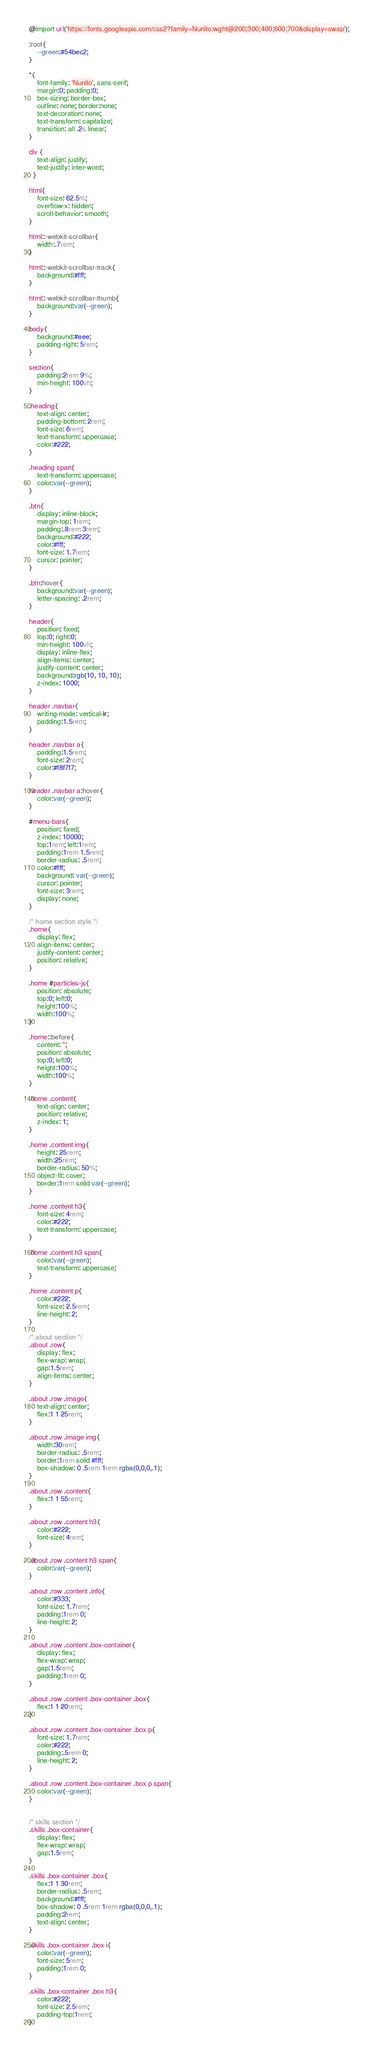<code> <loc_0><loc_0><loc_500><loc_500><_CSS_>@import url('https://fonts.googleapis.com/css2?family=Nunito:wght@200;300;400;600;700&display=swap');

:root{
    --green:#54bec2;
}

*{
    font-family: 'Nunito', sans-serif;
    margin:0; padding:0;
    box-sizing: border-box;
    outline: none; border:none;
    text-decoration: none;
    text-transform: capitalize;
    transition: all .2s linear;
}

div {
    text-align: justify;
    text-justify: inter-word;
  }
  
html{
    font-size: 62.5%;
    overflow-x: hidden;
    scroll-behavior: smooth;
}

html::-webkit-scrollbar{
    width:.7rem;
}

html::-webkit-scrollbar-track{
    background:#fff;
}

html::-webkit-scrollbar-thumb{
    background:var(--green);
}

body{
    background:#eee;
    padding-right: 5rem;
}

section{
    padding:2rem 9%;
    min-height: 100vh;
}

.heading{
    text-align: center;
    padding-bottom: 2rem;
    font-size: 6rem;
    text-transform: uppercase;
    color:#222;
}

.heading span{
    text-transform: uppercase;
    color:var(--green);
}

.btn{
    display: inline-block;
    margin-top: 1rem;
    padding:.8rem 3rem;
    background:#222;
    color:#fff;
    font-size: 1.7rem;
    cursor: pointer;
}

.btn:hover{
    background:var(--green);
    letter-spacing: .2rem;
}

header{
    position: fixed;
    top:0; right:0;
    min-height: 100vh;
    display: inline-flex;
    align-items: center;
    justify-content: center;
    background:rgb(10, 10, 10);
    z-index: 1000;
}

header .navbar{
    writing-mode: vertical-lr;
    padding:1.5rem;
}

header .navbar a{
    padding:1.5rem;
    font-size: 2rem;
    color:#f8f7f7;
}

header .navbar a:hover{
    color:var(--green);
}

#menu-bars{
    position: fixed;
    z-index: 10000;
    top:1rem; left:1rem;
    padding:1rem 1.5rem;
    border-radius: .5rem;
    color:#fff;
    background: var(--green);
    cursor: pointer;
    font-size: 3rem;
    display: none;
}

/* home section style */
.home{
    display: flex;
    align-items: center;
    justify-content: center;
    position: relative;
}

.home #particles-js{
    position: absolute;
    top:0; left:0;
    height:100%;
    width:100%;
}

.home::before{
    content: '';
    position: absolute;
    top:0; left:0;
    height:100%;
    width:100%;
}

.home .content{
    text-align: center;
    position: relative;
    z-index: 1;
}

.home .content img{
    height: 25rem;
    width:25rem;
    border-radius: 50%;
    object-fit: cover;
    border:1rem solid var(--green);
}

.home .content h3{
    font-size: 4rem;
    color:#222;
    text-transform: uppercase;
}

.home .content h3 span{
    color:var(--green);
    text-transform: uppercase;
}

.home .content p{
    color:#222;
    font-size: 2.5rem;
    line-height: 2;
}

/* about section */
.about .row{
    display: flex;
    flex-wrap: wrap;
    gap:1.5rem;
    align-items: center;
}

.about .row .image{
    text-align: center;
    flex:1 1 25rem;
}

.about .row .image img{
    width:30rem;
    border-radius: .5rem;
    border:1rem solid #fff;
    box-shadow: 0 .5rem 1rem rgba(0,0,0,.1);
}

.about .row .content{
    flex:1 1 55rem;
}

.about .row .content h3{
    color:#222;
    font-size: 4rem;
}

.about .row .content h3 span{
    color:var(--green);
}

.about .row .content .info{
    color:#333;
    font-size: 1.7rem;
    padding:1rem 0;
    line-height: 2;
}

.about .row .content .box-container{
    display: flex;
    flex-wrap: wrap;
    gap:1.5rem;
    padding:1rem 0;
}

.about .row .content .box-container .box{
    flex:1 1 20rem;
}

.about .row .content .box-container .box p{
    font-size: 1.7rem;
    color:#222;
    padding:.5rem 0;
    line-height: 2;
}

.about .row .content .box-container .box p span{
    color:var(--green);
}


/* skills section */
.skills .box-container{
    display: flex;
    flex-wrap: wrap;
    gap:1.5rem;
}

.skills .box-container .box{
    flex:1 1 30rem;
    border-radius: .5rem;
    background:#fff;
    box-shadow: 0 .5rem 1rem rgba(0,0,0,.1);
    padding:2rem;
    text-align: center;
}

.skills .box-container .box i{
    color:var(--green);
    font-size: 5rem;
    padding:1rem 0;
}

.skills .box-container .box h3{
    color:#222;
    font-size: 2.5rem;
    padding-top:1rem;
}
</code> 